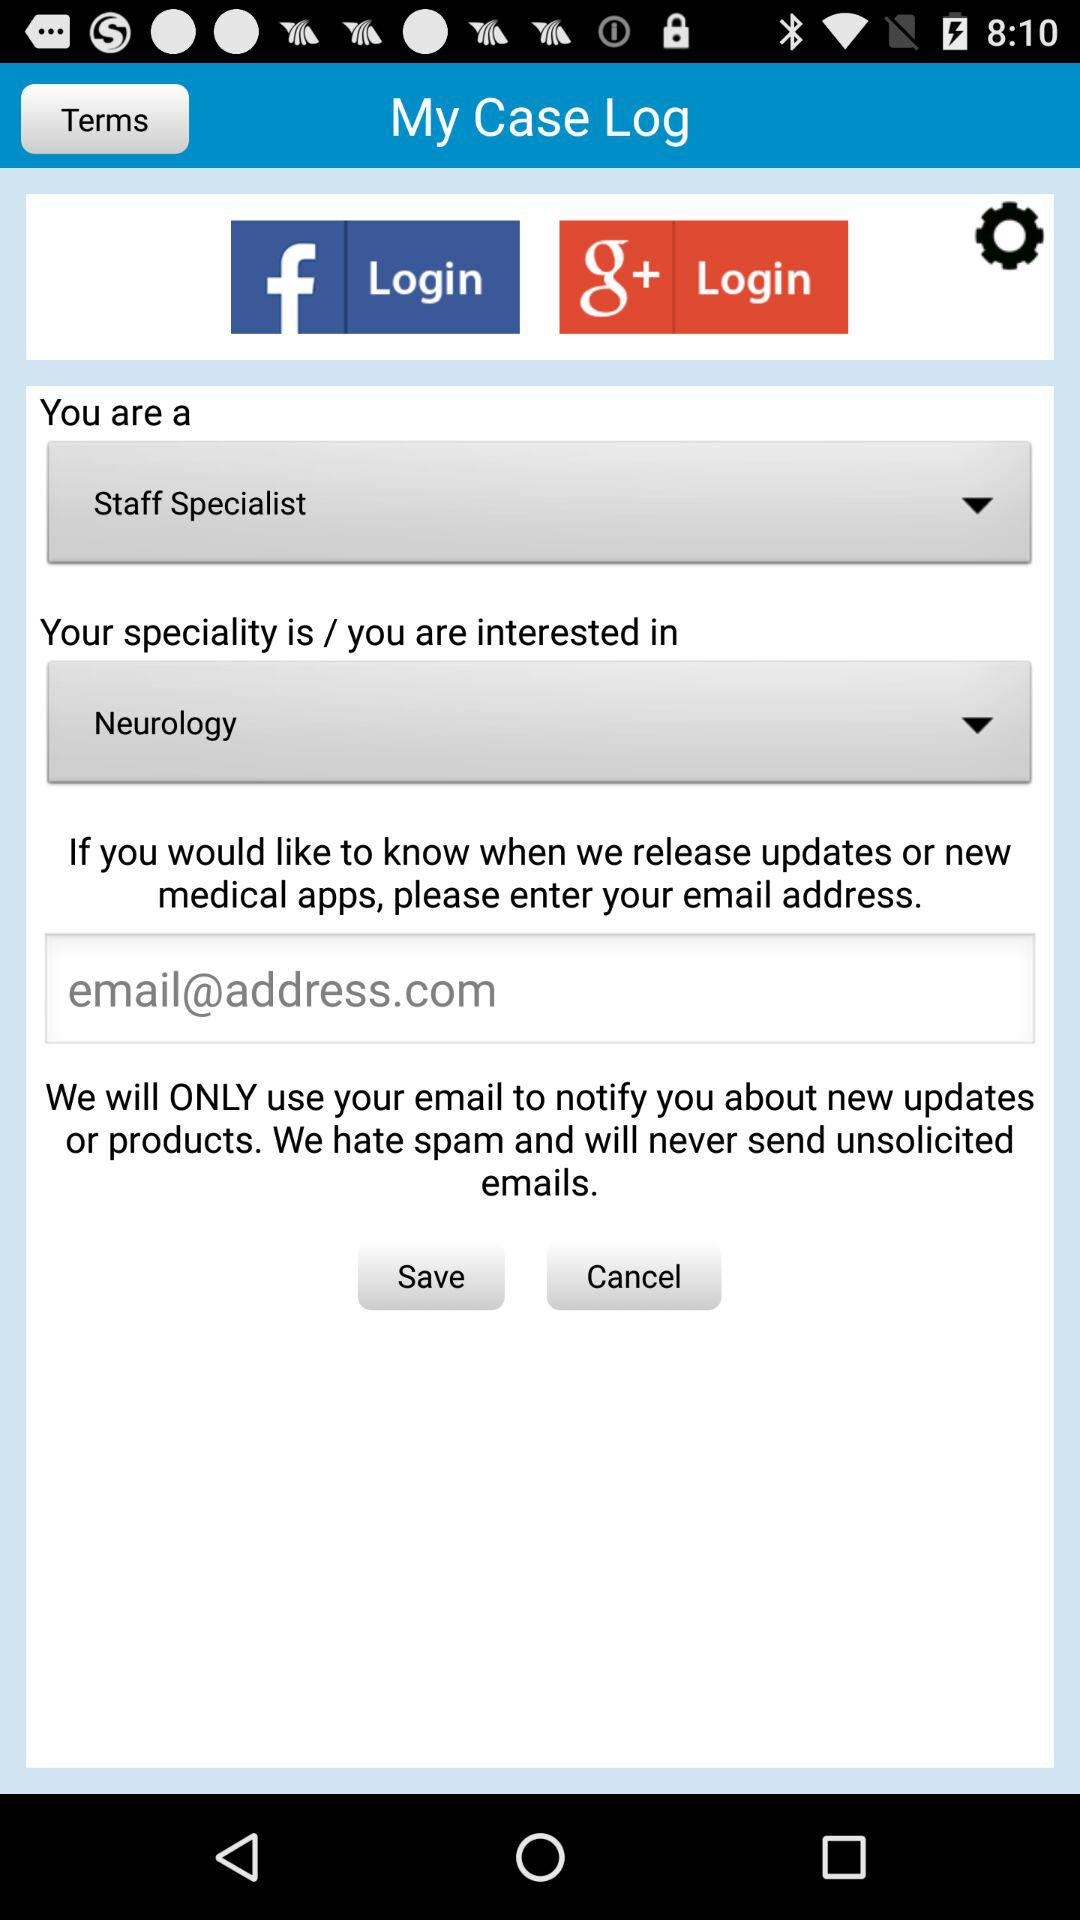Which specialist is selected? The selected specialist is "Staff". 